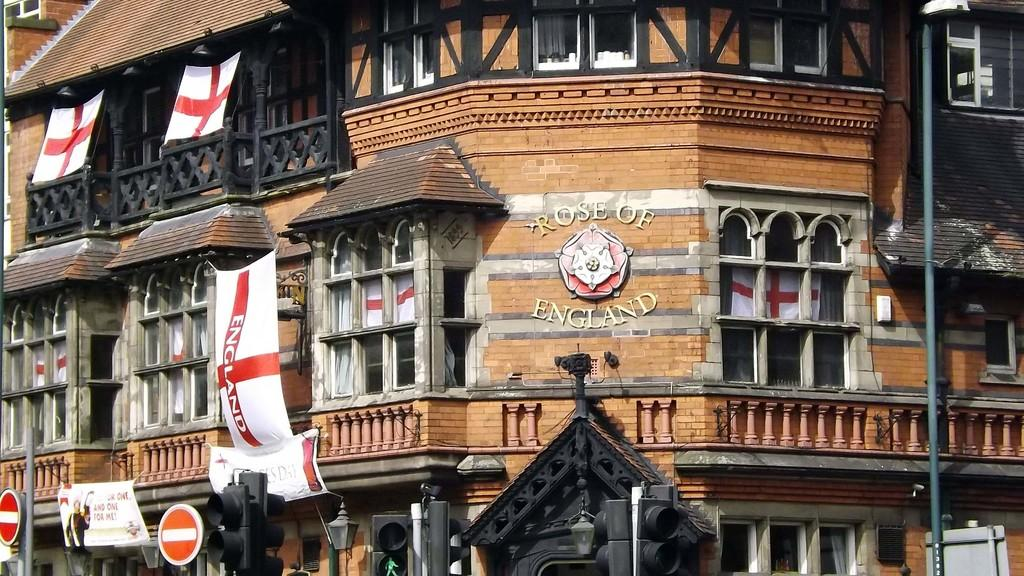<image>
Write a terse but informative summary of the picture. A building has the words "ROSE OF ENGLAND" on the side. 